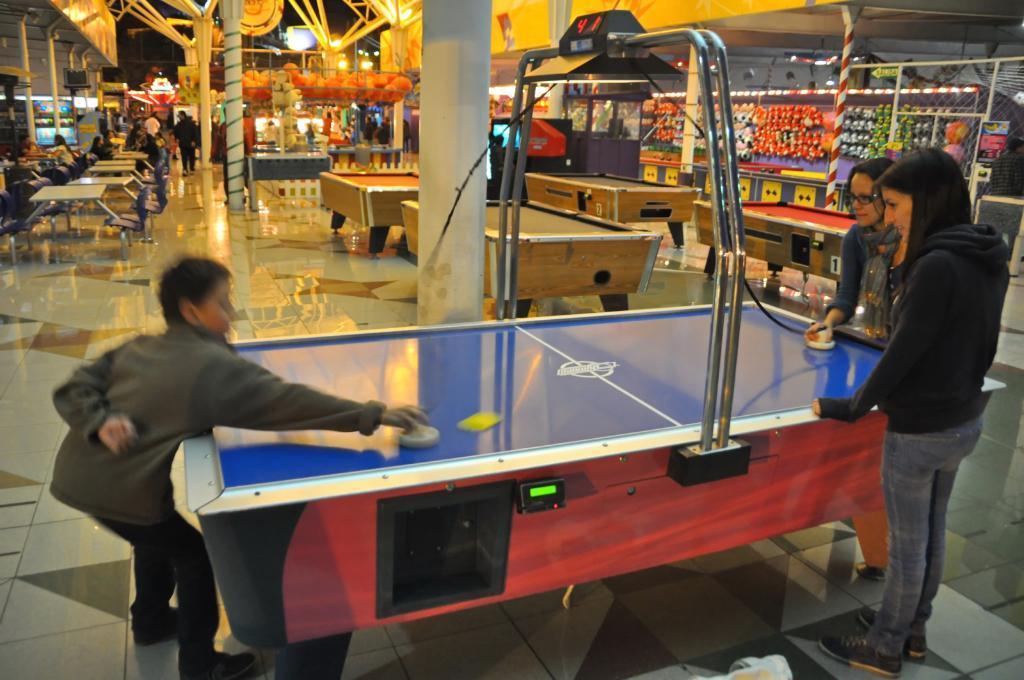Can you describe this image briefly? In this image i can see few people standing in front of a table. In the background i can see few people walking, few stores and few pillars. 